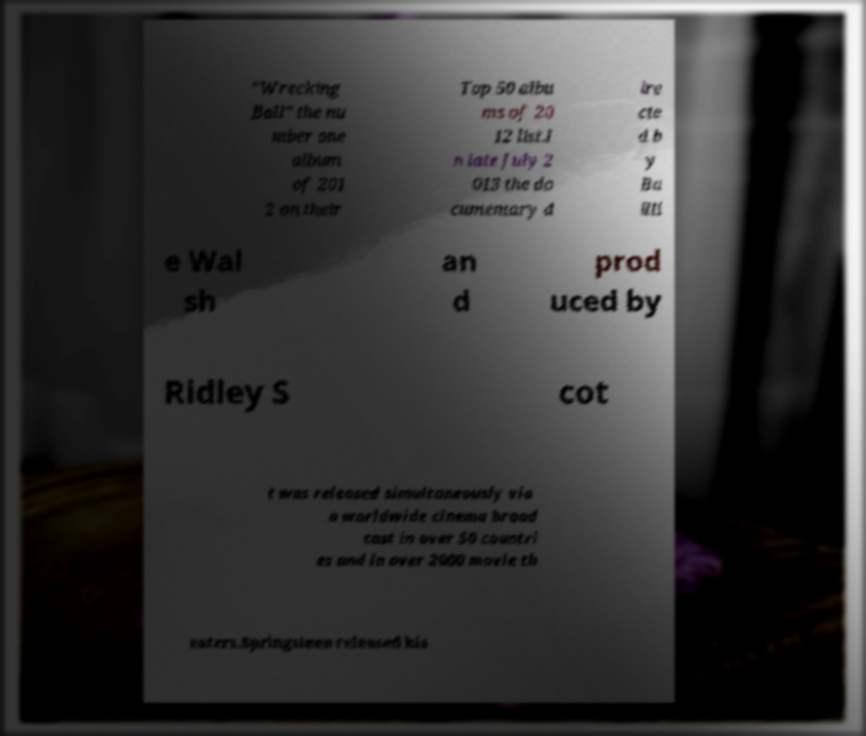I need the written content from this picture converted into text. Can you do that? "Wrecking Ball" the nu mber one album of 201 2 on their Top 50 albu ms of 20 12 list.I n late July 2 013 the do cumentary d ire cte d b y Ba illi e Wal sh an d prod uced by Ridley S cot t was released simultaneously via a worldwide cinema broad cast in over 50 countri es and in over 2000 movie th eaters.Springsteen released his 